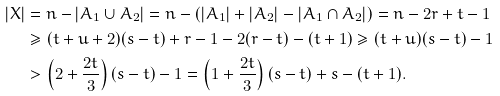Convert formula to latex. <formula><loc_0><loc_0><loc_500><loc_500>| X | & = n - | A _ { 1 } \cup A _ { 2 } | = n - ( | A _ { 1 } | + | A _ { 2 } | - | A _ { 1 } \cap A _ { 2 } | ) = n - 2 r + t - 1 \\ & \geq ( t + u + 2 ) ( s - t ) + r - 1 - 2 ( r - t ) - ( t + 1 ) \geq ( t + u ) ( s - t ) - 1 \\ & > \left ( 2 + \frac { 2 t } { 3 } \right ) ( s - t ) - 1 = \left ( 1 + \frac { 2 t } { 3 } \right ) ( s - t ) + s - ( t + 1 ) .</formula> 